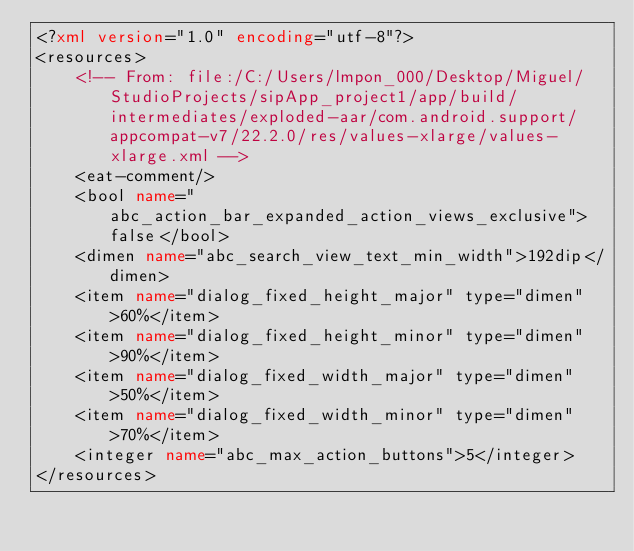Convert code to text. <code><loc_0><loc_0><loc_500><loc_500><_XML_><?xml version="1.0" encoding="utf-8"?>
<resources>
    <!-- From: file:/C:/Users/lmpon_000/Desktop/Miguel/StudioProjects/sipApp_project1/app/build/intermediates/exploded-aar/com.android.support/appcompat-v7/22.2.0/res/values-xlarge/values-xlarge.xml -->
    <eat-comment/>
    <bool name="abc_action_bar_expanded_action_views_exclusive">false</bool>
    <dimen name="abc_search_view_text_min_width">192dip</dimen>
    <item name="dialog_fixed_height_major" type="dimen">60%</item>
    <item name="dialog_fixed_height_minor" type="dimen">90%</item>
    <item name="dialog_fixed_width_major" type="dimen">50%</item>
    <item name="dialog_fixed_width_minor" type="dimen">70%</item>
    <integer name="abc_max_action_buttons">5</integer>
</resources></code> 